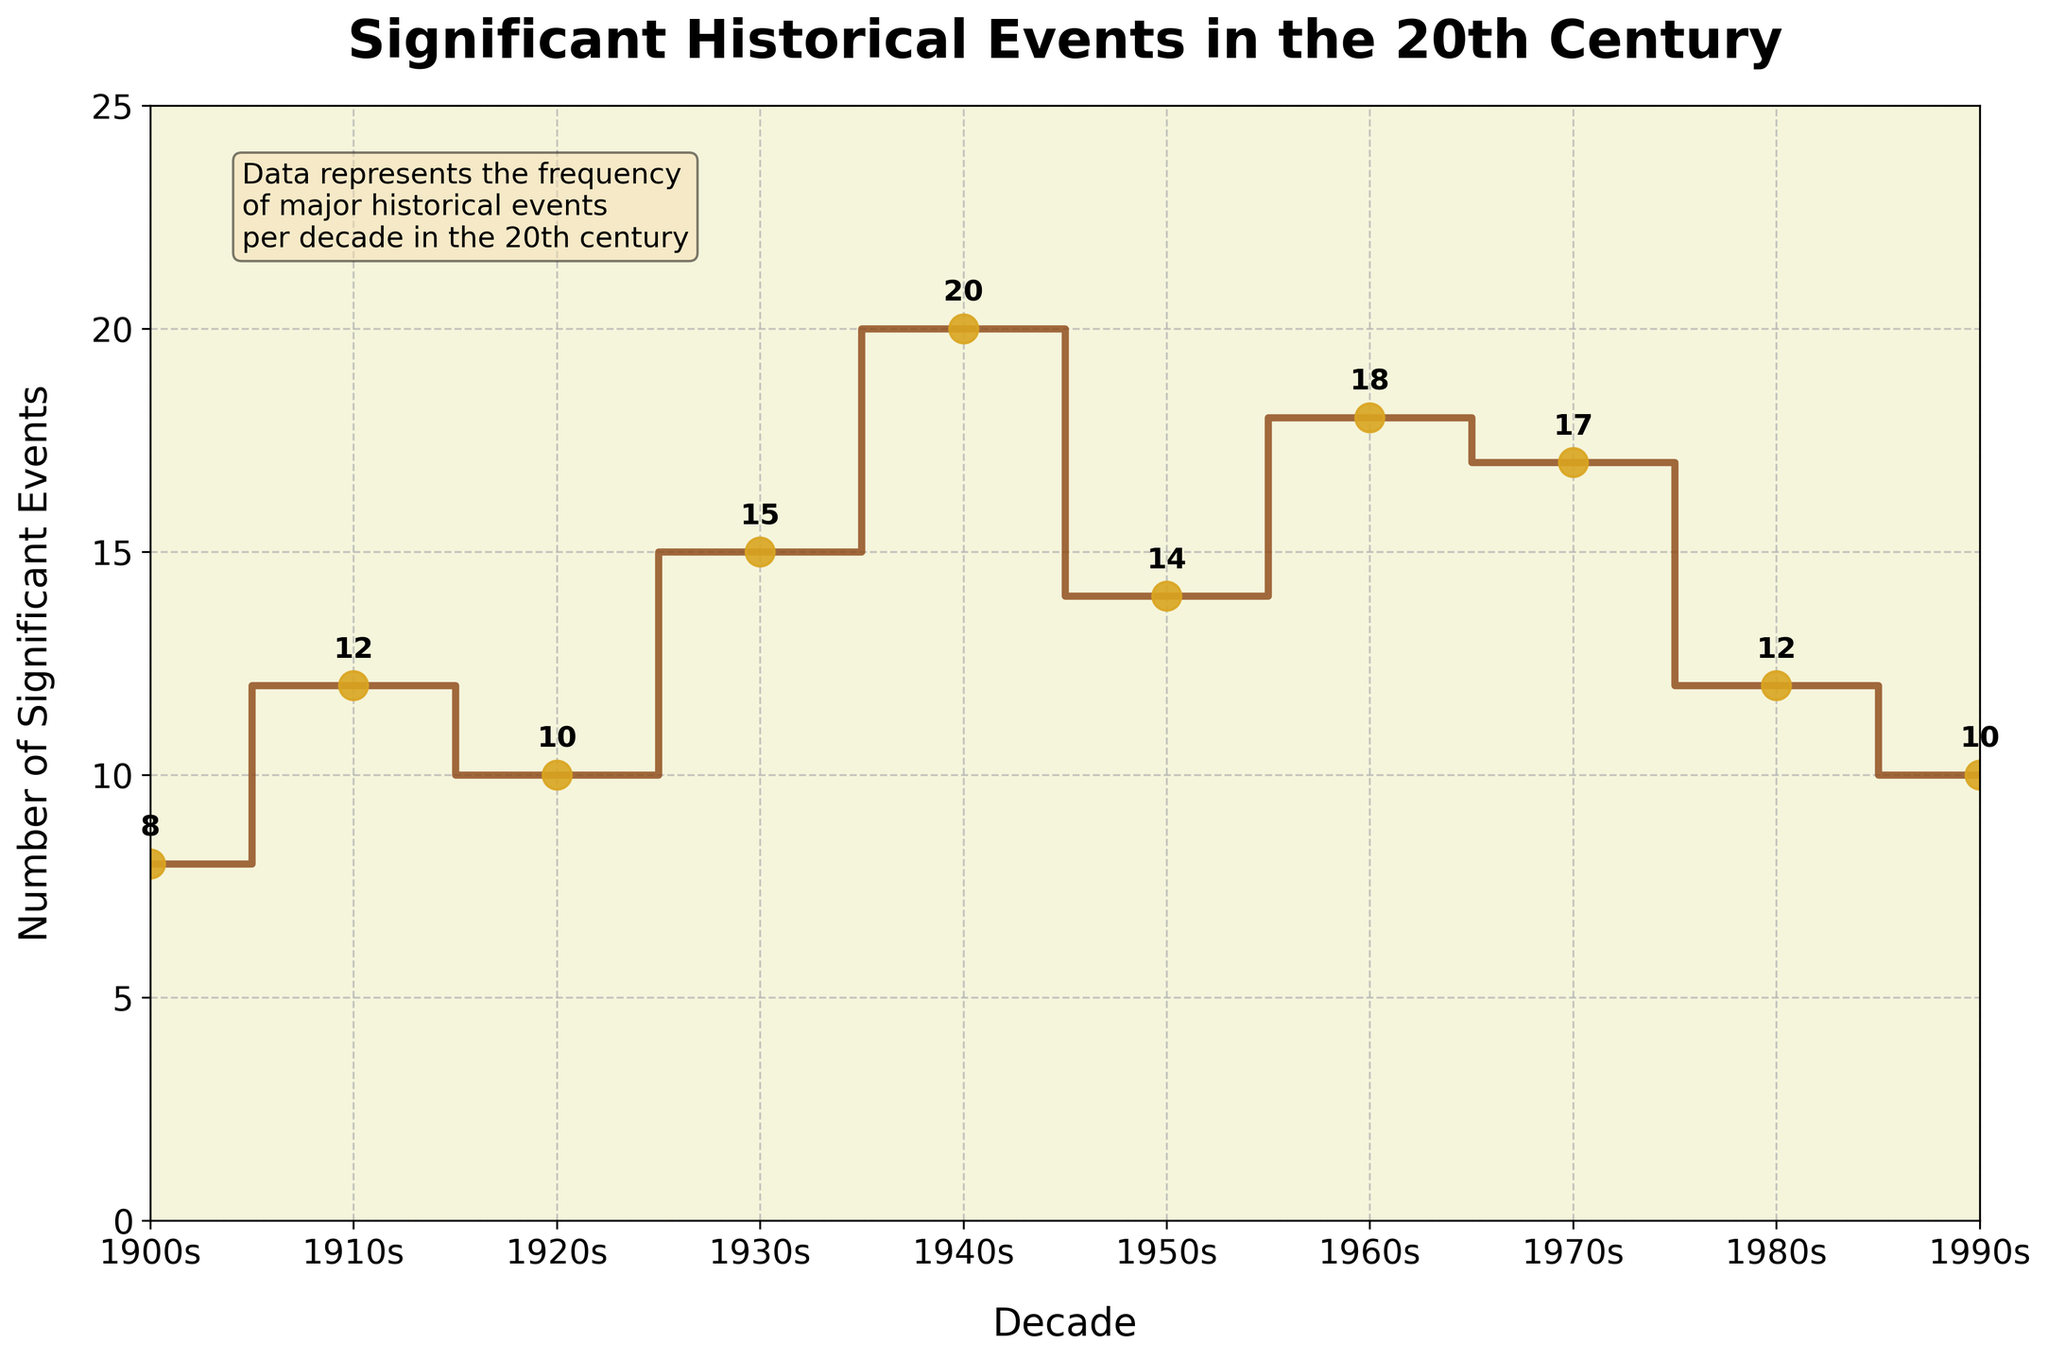What is the title of the plot? The title of the plot is written at the top of the figure. By reading the text at the top, you can identify it.
Answer: Significant Historical Events in the 20th Century How many significant historical events occurred in the 1940s? Look at the point corresponding to the 1940s on the x-axis and then read the y-value at that point.
Answer: 20 Which decade had the fewest significant historical events? To find this, you need to look at all the data points and determine which one has the lowest y-value.
Answer: 1900s What is the range of the number of significant historical events in the 20th century? Calculate the range by finding the difference between the maximum and minimum values of the data points on the y-axis. The maximum value is 20 (in the 1940s) and the minimum is 8 (in the 1900s). The range is 20 - 8.
Answer: 12 In which decades did the number of significant historical events exceed 15? Check each point on the x-axis where the y-value is greater than 15. These values can be found in the 1930s, 1940s, 1960s, and 1970s.
Answer: 1930s, 1940s, 1960s, 1970s What is the average number of significant historical events per decade? Sum all the y-values and divide by the number of decades. The sum is 8 + 12 + 10 + 15 + 20 + 14 + 18 + 17 + 12 + 10 = 136. There are 10 data points, so divide 136 by 10.
Answer: 13.6 Compare the 1930s and the 1960s in terms of significant historical events. Which decade had more? Look at the y-values for the 1930s and the 1960s. The 1930s had 15 events, and the 1960s had 18 events. Since 18 is greater than 15, the 1960s had more.
Answer: 1960s What trend can you observe in the number of significant historical events from the 1900s to the 1950s? Observe how the y-values change as you move from the 1900s to the 1950s on the x-axis. The numbers generally increase.
Answer: Increasing trend What decade represents the halfway point of the 20th century in this plot, and how many significant historical events occurred in that decade? The halfway point of the 20th century is the 1950s. You need to find the y-value corresponding to the 1950s on the x-axis.
Answer: 14 How many total significant historical events are illustrated in the plot? Sum all the y-values of the data points. Add 8 + 12 + 10 + 15 + 20 + 14 + 18 + 17 + 12 + 10 to get the total.
Answer: 136 